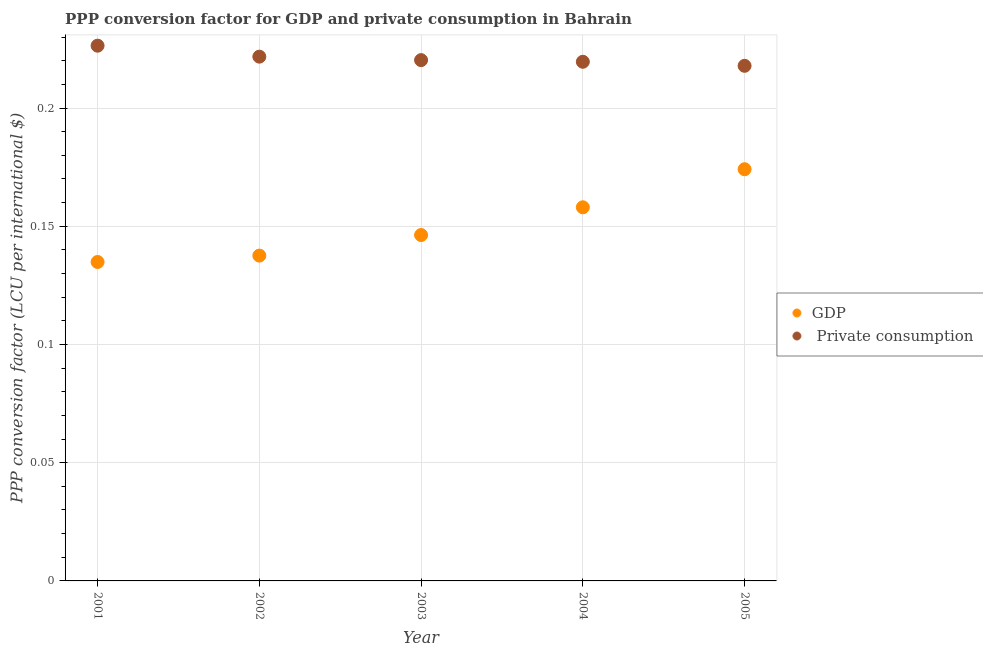How many different coloured dotlines are there?
Provide a short and direct response. 2. What is the ppp conversion factor for private consumption in 2002?
Your response must be concise. 0.22. Across all years, what is the maximum ppp conversion factor for gdp?
Offer a terse response. 0.17. Across all years, what is the minimum ppp conversion factor for private consumption?
Provide a short and direct response. 0.22. In which year was the ppp conversion factor for gdp minimum?
Give a very brief answer. 2001. What is the total ppp conversion factor for private consumption in the graph?
Offer a terse response. 1.11. What is the difference between the ppp conversion factor for private consumption in 2003 and that in 2005?
Give a very brief answer. 0. What is the difference between the ppp conversion factor for private consumption in 2003 and the ppp conversion factor for gdp in 2004?
Make the answer very short. 0.06. What is the average ppp conversion factor for private consumption per year?
Your response must be concise. 0.22. In the year 2002, what is the difference between the ppp conversion factor for gdp and ppp conversion factor for private consumption?
Make the answer very short. -0.08. In how many years, is the ppp conversion factor for private consumption greater than 0.11 LCU?
Keep it short and to the point. 5. What is the ratio of the ppp conversion factor for gdp in 2004 to that in 2005?
Provide a succinct answer. 0.91. What is the difference between the highest and the second highest ppp conversion factor for gdp?
Ensure brevity in your answer.  0.02. What is the difference between the highest and the lowest ppp conversion factor for gdp?
Make the answer very short. 0.04. Is the sum of the ppp conversion factor for gdp in 2002 and 2005 greater than the maximum ppp conversion factor for private consumption across all years?
Give a very brief answer. Yes. Is the ppp conversion factor for gdp strictly greater than the ppp conversion factor for private consumption over the years?
Provide a short and direct response. No. How many dotlines are there?
Offer a very short reply. 2. What is the difference between two consecutive major ticks on the Y-axis?
Your response must be concise. 0.05. Are the values on the major ticks of Y-axis written in scientific E-notation?
Provide a short and direct response. No. Where does the legend appear in the graph?
Ensure brevity in your answer.  Center right. How many legend labels are there?
Ensure brevity in your answer.  2. How are the legend labels stacked?
Provide a succinct answer. Vertical. What is the title of the graph?
Offer a terse response. PPP conversion factor for GDP and private consumption in Bahrain. What is the label or title of the X-axis?
Provide a short and direct response. Year. What is the label or title of the Y-axis?
Provide a succinct answer. PPP conversion factor (LCU per international $). What is the PPP conversion factor (LCU per international $) of GDP in 2001?
Ensure brevity in your answer.  0.13. What is the PPP conversion factor (LCU per international $) of  Private consumption in 2001?
Ensure brevity in your answer.  0.23. What is the PPP conversion factor (LCU per international $) of GDP in 2002?
Provide a succinct answer. 0.14. What is the PPP conversion factor (LCU per international $) of  Private consumption in 2002?
Provide a short and direct response. 0.22. What is the PPP conversion factor (LCU per international $) of GDP in 2003?
Ensure brevity in your answer.  0.15. What is the PPP conversion factor (LCU per international $) in  Private consumption in 2003?
Ensure brevity in your answer.  0.22. What is the PPP conversion factor (LCU per international $) of GDP in 2004?
Your answer should be very brief. 0.16. What is the PPP conversion factor (LCU per international $) of  Private consumption in 2004?
Provide a succinct answer. 0.22. What is the PPP conversion factor (LCU per international $) of GDP in 2005?
Keep it short and to the point. 0.17. What is the PPP conversion factor (LCU per international $) of  Private consumption in 2005?
Ensure brevity in your answer.  0.22. Across all years, what is the maximum PPP conversion factor (LCU per international $) of GDP?
Your answer should be very brief. 0.17. Across all years, what is the maximum PPP conversion factor (LCU per international $) of  Private consumption?
Your answer should be compact. 0.23. Across all years, what is the minimum PPP conversion factor (LCU per international $) in GDP?
Offer a very short reply. 0.13. Across all years, what is the minimum PPP conversion factor (LCU per international $) in  Private consumption?
Your answer should be very brief. 0.22. What is the total PPP conversion factor (LCU per international $) of GDP in the graph?
Provide a short and direct response. 0.75. What is the total PPP conversion factor (LCU per international $) of  Private consumption in the graph?
Give a very brief answer. 1.11. What is the difference between the PPP conversion factor (LCU per international $) in GDP in 2001 and that in 2002?
Offer a terse response. -0. What is the difference between the PPP conversion factor (LCU per international $) of  Private consumption in 2001 and that in 2002?
Your answer should be compact. 0. What is the difference between the PPP conversion factor (LCU per international $) of GDP in 2001 and that in 2003?
Make the answer very short. -0.01. What is the difference between the PPP conversion factor (LCU per international $) in  Private consumption in 2001 and that in 2003?
Ensure brevity in your answer.  0.01. What is the difference between the PPP conversion factor (LCU per international $) in GDP in 2001 and that in 2004?
Your response must be concise. -0.02. What is the difference between the PPP conversion factor (LCU per international $) of  Private consumption in 2001 and that in 2004?
Provide a succinct answer. 0.01. What is the difference between the PPP conversion factor (LCU per international $) in GDP in 2001 and that in 2005?
Provide a succinct answer. -0.04. What is the difference between the PPP conversion factor (LCU per international $) of  Private consumption in 2001 and that in 2005?
Provide a succinct answer. 0.01. What is the difference between the PPP conversion factor (LCU per international $) in GDP in 2002 and that in 2003?
Your response must be concise. -0.01. What is the difference between the PPP conversion factor (LCU per international $) of  Private consumption in 2002 and that in 2003?
Provide a succinct answer. 0. What is the difference between the PPP conversion factor (LCU per international $) of GDP in 2002 and that in 2004?
Give a very brief answer. -0.02. What is the difference between the PPP conversion factor (LCU per international $) of  Private consumption in 2002 and that in 2004?
Provide a succinct answer. 0. What is the difference between the PPP conversion factor (LCU per international $) in GDP in 2002 and that in 2005?
Provide a succinct answer. -0.04. What is the difference between the PPP conversion factor (LCU per international $) in  Private consumption in 2002 and that in 2005?
Keep it short and to the point. 0. What is the difference between the PPP conversion factor (LCU per international $) of GDP in 2003 and that in 2004?
Ensure brevity in your answer.  -0.01. What is the difference between the PPP conversion factor (LCU per international $) of  Private consumption in 2003 and that in 2004?
Give a very brief answer. 0. What is the difference between the PPP conversion factor (LCU per international $) in GDP in 2003 and that in 2005?
Ensure brevity in your answer.  -0.03. What is the difference between the PPP conversion factor (LCU per international $) of  Private consumption in 2003 and that in 2005?
Your answer should be very brief. 0. What is the difference between the PPP conversion factor (LCU per international $) of GDP in 2004 and that in 2005?
Give a very brief answer. -0.02. What is the difference between the PPP conversion factor (LCU per international $) of  Private consumption in 2004 and that in 2005?
Give a very brief answer. 0. What is the difference between the PPP conversion factor (LCU per international $) in GDP in 2001 and the PPP conversion factor (LCU per international $) in  Private consumption in 2002?
Offer a very short reply. -0.09. What is the difference between the PPP conversion factor (LCU per international $) of GDP in 2001 and the PPP conversion factor (LCU per international $) of  Private consumption in 2003?
Offer a very short reply. -0.09. What is the difference between the PPP conversion factor (LCU per international $) in GDP in 2001 and the PPP conversion factor (LCU per international $) in  Private consumption in 2004?
Provide a succinct answer. -0.08. What is the difference between the PPP conversion factor (LCU per international $) of GDP in 2001 and the PPP conversion factor (LCU per international $) of  Private consumption in 2005?
Make the answer very short. -0.08. What is the difference between the PPP conversion factor (LCU per international $) in GDP in 2002 and the PPP conversion factor (LCU per international $) in  Private consumption in 2003?
Offer a very short reply. -0.08. What is the difference between the PPP conversion factor (LCU per international $) of GDP in 2002 and the PPP conversion factor (LCU per international $) of  Private consumption in 2004?
Provide a short and direct response. -0.08. What is the difference between the PPP conversion factor (LCU per international $) of GDP in 2002 and the PPP conversion factor (LCU per international $) of  Private consumption in 2005?
Your answer should be very brief. -0.08. What is the difference between the PPP conversion factor (LCU per international $) in GDP in 2003 and the PPP conversion factor (LCU per international $) in  Private consumption in 2004?
Your answer should be very brief. -0.07. What is the difference between the PPP conversion factor (LCU per international $) of GDP in 2003 and the PPP conversion factor (LCU per international $) of  Private consumption in 2005?
Your answer should be very brief. -0.07. What is the difference between the PPP conversion factor (LCU per international $) in GDP in 2004 and the PPP conversion factor (LCU per international $) in  Private consumption in 2005?
Make the answer very short. -0.06. What is the average PPP conversion factor (LCU per international $) of GDP per year?
Provide a succinct answer. 0.15. What is the average PPP conversion factor (LCU per international $) of  Private consumption per year?
Make the answer very short. 0.22. In the year 2001, what is the difference between the PPP conversion factor (LCU per international $) of GDP and PPP conversion factor (LCU per international $) of  Private consumption?
Keep it short and to the point. -0.09. In the year 2002, what is the difference between the PPP conversion factor (LCU per international $) in GDP and PPP conversion factor (LCU per international $) in  Private consumption?
Give a very brief answer. -0.08. In the year 2003, what is the difference between the PPP conversion factor (LCU per international $) in GDP and PPP conversion factor (LCU per international $) in  Private consumption?
Give a very brief answer. -0.07. In the year 2004, what is the difference between the PPP conversion factor (LCU per international $) in GDP and PPP conversion factor (LCU per international $) in  Private consumption?
Offer a terse response. -0.06. In the year 2005, what is the difference between the PPP conversion factor (LCU per international $) of GDP and PPP conversion factor (LCU per international $) of  Private consumption?
Provide a succinct answer. -0.04. What is the ratio of the PPP conversion factor (LCU per international $) in GDP in 2001 to that in 2002?
Keep it short and to the point. 0.98. What is the ratio of the PPP conversion factor (LCU per international $) of  Private consumption in 2001 to that in 2002?
Provide a succinct answer. 1.02. What is the ratio of the PPP conversion factor (LCU per international $) of GDP in 2001 to that in 2003?
Your answer should be compact. 0.92. What is the ratio of the PPP conversion factor (LCU per international $) of  Private consumption in 2001 to that in 2003?
Ensure brevity in your answer.  1.03. What is the ratio of the PPP conversion factor (LCU per international $) of GDP in 2001 to that in 2004?
Provide a succinct answer. 0.85. What is the ratio of the PPP conversion factor (LCU per international $) of  Private consumption in 2001 to that in 2004?
Your response must be concise. 1.03. What is the ratio of the PPP conversion factor (LCU per international $) of GDP in 2001 to that in 2005?
Offer a very short reply. 0.77. What is the ratio of the PPP conversion factor (LCU per international $) in  Private consumption in 2001 to that in 2005?
Keep it short and to the point. 1.04. What is the ratio of the PPP conversion factor (LCU per international $) in GDP in 2002 to that in 2003?
Provide a short and direct response. 0.94. What is the ratio of the PPP conversion factor (LCU per international $) in GDP in 2002 to that in 2004?
Make the answer very short. 0.87. What is the ratio of the PPP conversion factor (LCU per international $) of  Private consumption in 2002 to that in 2004?
Ensure brevity in your answer.  1.01. What is the ratio of the PPP conversion factor (LCU per international $) in GDP in 2002 to that in 2005?
Your answer should be compact. 0.79. What is the ratio of the PPP conversion factor (LCU per international $) of  Private consumption in 2002 to that in 2005?
Provide a succinct answer. 1.02. What is the ratio of the PPP conversion factor (LCU per international $) in GDP in 2003 to that in 2004?
Keep it short and to the point. 0.93. What is the ratio of the PPP conversion factor (LCU per international $) in  Private consumption in 2003 to that in 2004?
Provide a short and direct response. 1. What is the ratio of the PPP conversion factor (LCU per international $) of GDP in 2003 to that in 2005?
Your answer should be very brief. 0.84. What is the ratio of the PPP conversion factor (LCU per international $) of  Private consumption in 2003 to that in 2005?
Your response must be concise. 1.01. What is the ratio of the PPP conversion factor (LCU per international $) of GDP in 2004 to that in 2005?
Give a very brief answer. 0.91. What is the ratio of the PPP conversion factor (LCU per international $) of  Private consumption in 2004 to that in 2005?
Offer a terse response. 1.01. What is the difference between the highest and the second highest PPP conversion factor (LCU per international $) of GDP?
Your response must be concise. 0.02. What is the difference between the highest and the second highest PPP conversion factor (LCU per international $) in  Private consumption?
Your answer should be compact. 0. What is the difference between the highest and the lowest PPP conversion factor (LCU per international $) in GDP?
Make the answer very short. 0.04. What is the difference between the highest and the lowest PPP conversion factor (LCU per international $) in  Private consumption?
Your answer should be compact. 0.01. 